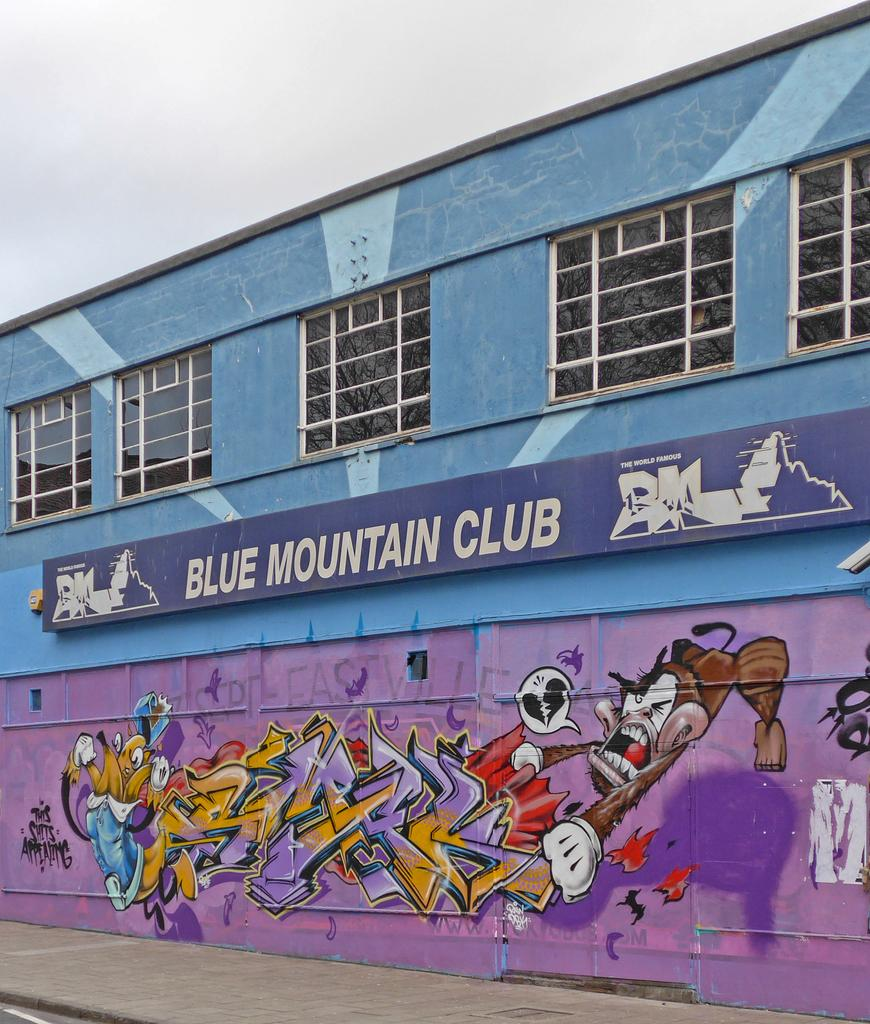<image>
Relay a brief, clear account of the picture shown. Grafitti drawing of a monkey under a sign that says Blue Mountain Club. 